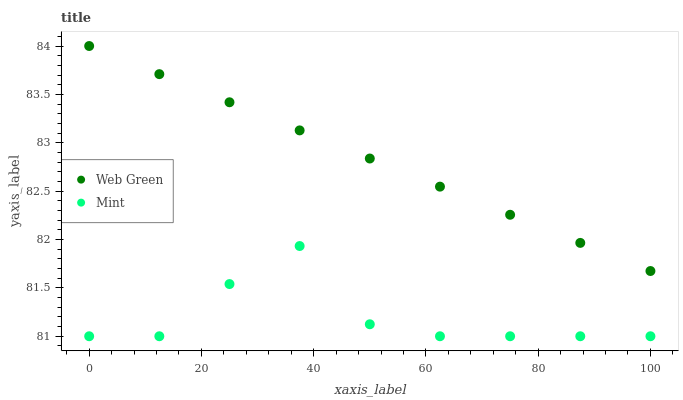Does Mint have the minimum area under the curve?
Answer yes or no. Yes. Does Web Green have the maximum area under the curve?
Answer yes or no. Yes. Does Web Green have the minimum area under the curve?
Answer yes or no. No. Is Web Green the smoothest?
Answer yes or no. Yes. Is Mint the roughest?
Answer yes or no. Yes. Is Web Green the roughest?
Answer yes or no. No. Does Mint have the lowest value?
Answer yes or no. Yes. Does Web Green have the lowest value?
Answer yes or no. No. Does Web Green have the highest value?
Answer yes or no. Yes. Is Mint less than Web Green?
Answer yes or no. Yes. Is Web Green greater than Mint?
Answer yes or no. Yes. Does Mint intersect Web Green?
Answer yes or no. No. 